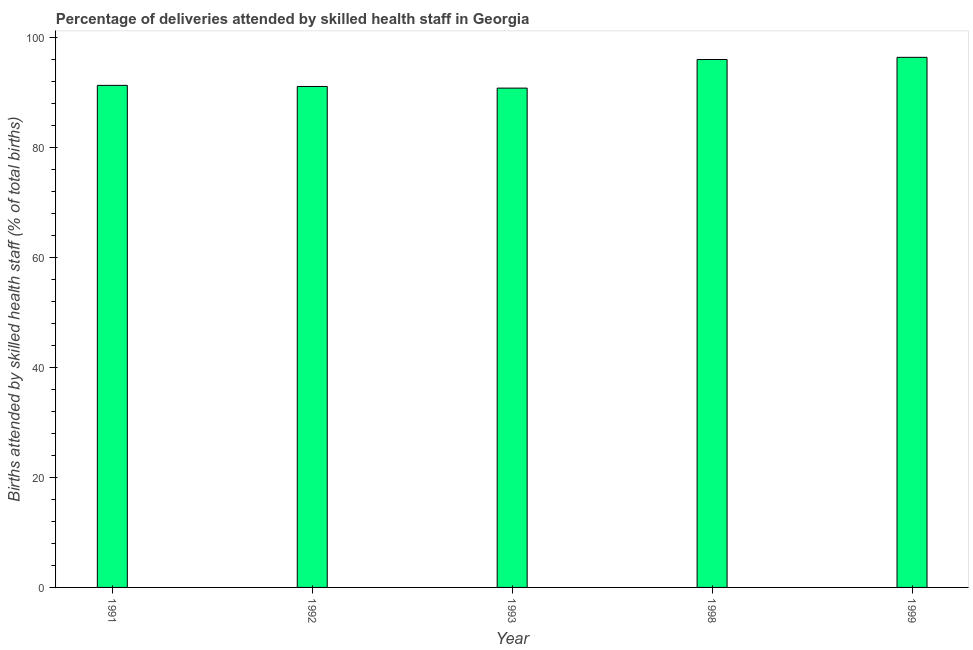Does the graph contain any zero values?
Your answer should be compact. No. Does the graph contain grids?
Offer a terse response. No. What is the title of the graph?
Ensure brevity in your answer.  Percentage of deliveries attended by skilled health staff in Georgia. What is the label or title of the Y-axis?
Provide a short and direct response. Births attended by skilled health staff (% of total births). What is the number of births attended by skilled health staff in 1999?
Provide a succinct answer. 96.4. Across all years, what is the maximum number of births attended by skilled health staff?
Provide a short and direct response. 96.4. Across all years, what is the minimum number of births attended by skilled health staff?
Make the answer very short. 90.8. In which year was the number of births attended by skilled health staff maximum?
Your response must be concise. 1999. In which year was the number of births attended by skilled health staff minimum?
Offer a very short reply. 1993. What is the sum of the number of births attended by skilled health staff?
Your answer should be compact. 465.6. What is the difference between the number of births attended by skilled health staff in 1992 and 1999?
Ensure brevity in your answer.  -5.3. What is the average number of births attended by skilled health staff per year?
Provide a short and direct response. 93.12. What is the median number of births attended by skilled health staff?
Provide a succinct answer. 91.3. In how many years, is the number of births attended by skilled health staff greater than 24 %?
Give a very brief answer. 5. Do a majority of the years between 1998 and 1993 (inclusive) have number of births attended by skilled health staff greater than 80 %?
Your response must be concise. No. What is the ratio of the number of births attended by skilled health staff in 1993 to that in 1999?
Offer a terse response. 0.94. Is the difference between the number of births attended by skilled health staff in 1993 and 1998 greater than the difference between any two years?
Make the answer very short. No. What is the difference between the highest and the lowest number of births attended by skilled health staff?
Your answer should be very brief. 5.6. In how many years, is the number of births attended by skilled health staff greater than the average number of births attended by skilled health staff taken over all years?
Your answer should be very brief. 2. Are all the bars in the graph horizontal?
Your answer should be compact. No. What is the difference between two consecutive major ticks on the Y-axis?
Your answer should be very brief. 20. What is the Births attended by skilled health staff (% of total births) in 1991?
Give a very brief answer. 91.3. What is the Births attended by skilled health staff (% of total births) of 1992?
Provide a succinct answer. 91.1. What is the Births attended by skilled health staff (% of total births) in 1993?
Ensure brevity in your answer.  90.8. What is the Births attended by skilled health staff (% of total births) in 1998?
Give a very brief answer. 96. What is the Births attended by skilled health staff (% of total births) in 1999?
Your response must be concise. 96.4. What is the difference between the Births attended by skilled health staff (% of total births) in 1991 and 1992?
Keep it short and to the point. 0.2. What is the difference between the Births attended by skilled health staff (% of total births) in 1991 and 1999?
Offer a terse response. -5.1. What is the difference between the Births attended by skilled health staff (% of total births) in 1992 and 1998?
Your answer should be very brief. -4.9. What is the difference between the Births attended by skilled health staff (% of total births) in 1998 and 1999?
Your answer should be very brief. -0.4. What is the ratio of the Births attended by skilled health staff (% of total births) in 1991 to that in 1998?
Provide a short and direct response. 0.95. What is the ratio of the Births attended by skilled health staff (% of total births) in 1991 to that in 1999?
Provide a succinct answer. 0.95. What is the ratio of the Births attended by skilled health staff (% of total births) in 1992 to that in 1998?
Provide a succinct answer. 0.95. What is the ratio of the Births attended by skilled health staff (% of total births) in 1992 to that in 1999?
Your response must be concise. 0.94. What is the ratio of the Births attended by skilled health staff (% of total births) in 1993 to that in 1998?
Give a very brief answer. 0.95. What is the ratio of the Births attended by skilled health staff (% of total births) in 1993 to that in 1999?
Keep it short and to the point. 0.94. 